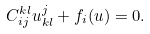<formula> <loc_0><loc_0><loc_500><loc_500>C ^ { k l } _ { i j } u ^ { j } _ { k l } + f _ { i } ( u ) = 0 .</formula> 